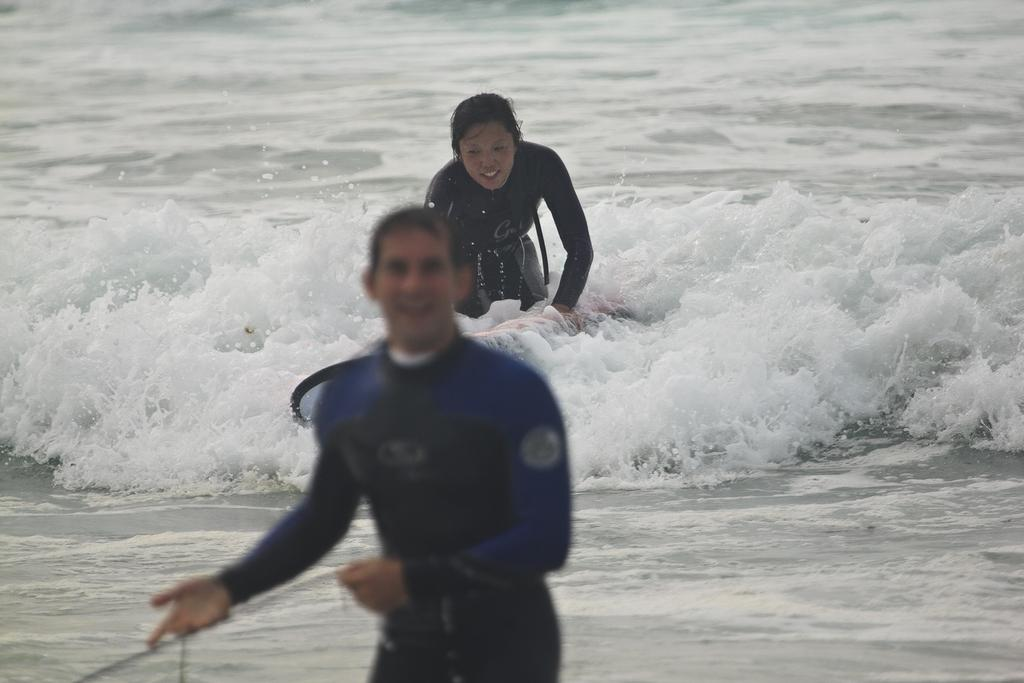How many people are in the image? There are two persons in the image. What are the persons doing in the image? The persons are surfing on the water. What equipment are the persons using for surfing? The persons are using surfboards. What is the emotional expression of the persons in the image? The persons are smiling. What is one person holding while surfing? One person is holding a rope. What type of screw can be seen in the image? There is no screw present in the image; it features two persons surfing on the water. 